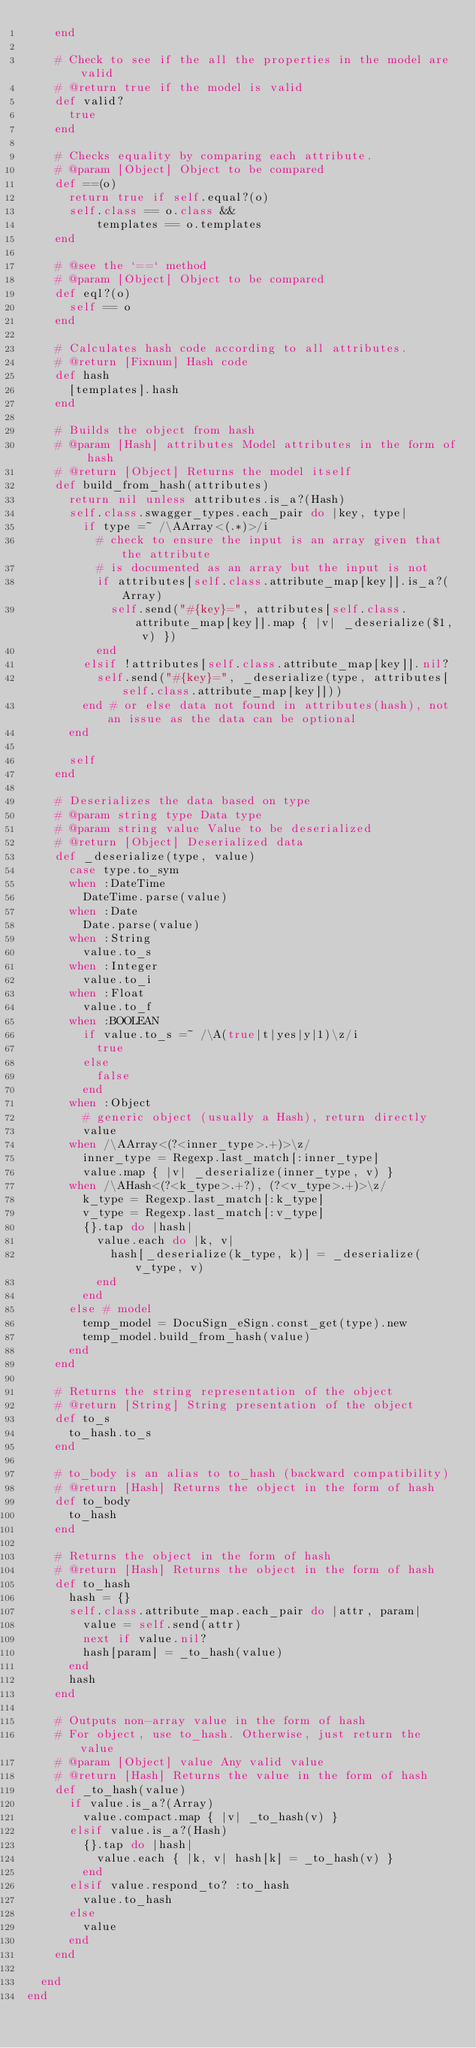Convert code to text. <code><loc_0><loc_0><loc_500><loc_500><_Ruby_>    end

    # Check to see if the all the properties in the model are valid
    # @return true if the model is valid
    def valid?
      true
    end

    # Checks equality by comparing each attribute.
    # @param [Object] Object to be compared
    def ==(o)
      return true if self.equal?(o)
      self.class == o.class &&
          templates == o.templates
    end

    # @see the `==` method
    # @param [Object] Object to be compared
    def eql?(o)
      self == o
    end

    # Calculates hash code according to all attributes.
    # @return [Fixnum] Hash code
    def hash
      [templates].hash
    end

    # Builds the object from hash
    # @param [Hash] attributes Model attributes in the form of hash
    # @return [Object] Returns the model itself
    def build_from_hash(attributes)
      return nil unless attributes.is_a?(Hash)
      self.class.swagger_types.each_pair do |key, type|
        if type =~ /\AArray<(.*)>/i
          # check to ensure the input is an array given that the attribute
          # is documented as an array but the input is not
          if attributes[self.class.attribute_map[key]].is_a?(Array)
            self.send("#{key}=", attributes[self.class.attribute_map[key]].map { |v| _deserialize($1, v) })
          end
        elsif !attributes[self.class.attribute_map[key]].nil?
          self.send("#{key}=", _deserialize(type, attributes[self.class.attribute_map[key]]))
        end # or else data not found in attributes(hash), not an issue as the data can be optional
      end

      self
    end

    # Deserializes the data based on type
    # @param string type Data type
    # @param string value Value to be deserialized
    # @return [Object] Deserialized data
    def _deserialize(type, value)
      case type.to_sym
      when :DateTime
        DateTime.parse(value)
      when :Date
        Date.parse(value)
      when :String
        value.to_s
      when :Integer
        value.to_i
      when :Float
        value.to_f
      when :BOOLEAN
        if value.to_s =~ /\A(true|t|yes|y|1)\z/i
          true
        else
          false
        end
      when :Object
        # generic object (usually a Hash), return directly
        value
      when /\AArray<(?<inner_type>.+)>\z/
        inner_type = Regexp.last_match[:inner_type]
        value.map { |v| _deserialize(inner_type, v) }
      when /\AHash<(?<k_type>.+?), (?<v_type>.+)>\z/
        k_type = Regexp.last_match[:k_type]
        v_type = Regexp.last_match[:v_type]
        {}.tap do |hash|
          value.each do |k, v|
            hash[_deserialize(k_type, k)] = _deserialize(v_type, v)
          end
        end
      else # model
        temp_model = DocuSign_eSign.const_get(type).new
        temp_model.build_from_hash(value)
      end
    end

    # Returns the string representation of the object
    # @return [String] String presentation of the object
    def to_s
      to_hash.to_s
    end

    # to_body is an alias to to_hash (backward compatibility)
    # @return [Hash] Returns the object in the form of hash
    def to_body
      to_hash
    end

    # Returns the object in the form of hash
    # @return [Hash] Returns the object in the form of hash
    def to_hash
      hash = {}
      self.class.attribute_map.each_pair do |attr, param|
        value = self.send(attr)
        next if value.nil?
        hash[param] = _to_hash(value)
      end
      hash
    end

    # Outputs non-array value in the form of hash
    # For object, use to_hash. Otherwise, just return the value
    # @param [Object] value Any valid value
    # @return [Hash] Returns the value in the form of hash
    def _to_hash(value)
      if value.is_a?(Array)
        value.compact.map { |v| _to_hash(v) }
      elsif value.is_a?(Hash)
        {}.tap do |hash|
          value.each { |k, v| hash[k] = _to_hash(v) }
        end
      elsif value.respond_to? :to_hash
        value.to_hash
      else
        value
      end
    end

  end
end
</code> 